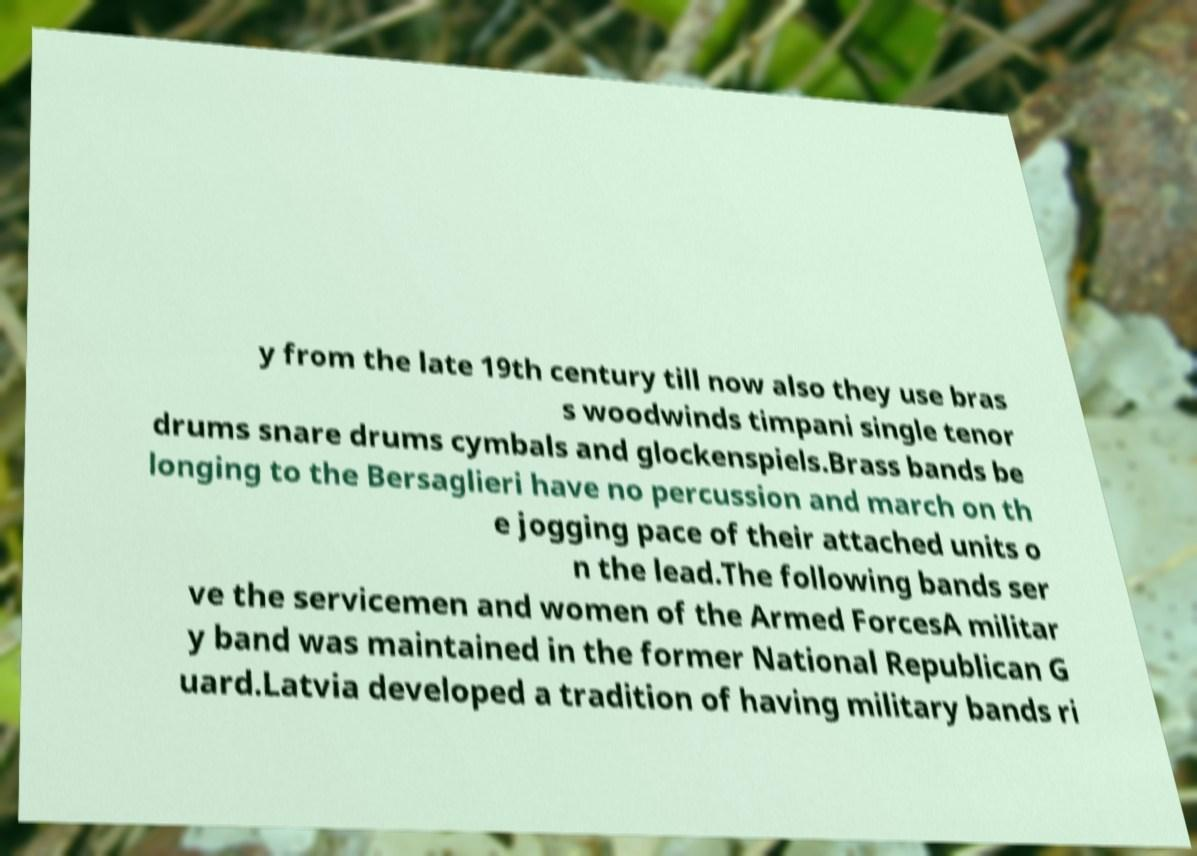There's text embedded in this image that I need extracted. Can you transcribe it verbatim? y from the late 19th century till now also they use bras s woodwinds timpani single tenor drums snare drums cymbals and glockenspiels.Brass bands be longing to the Bersaglieri have no percussion and march on th e jogging pace of their attached units o n the lead.The following bands ser ve the servicemen and women of the Armed ForcesA militar y band was maintained in the former National Republican G uard.Latvia developed a tradition of having military bands ri 